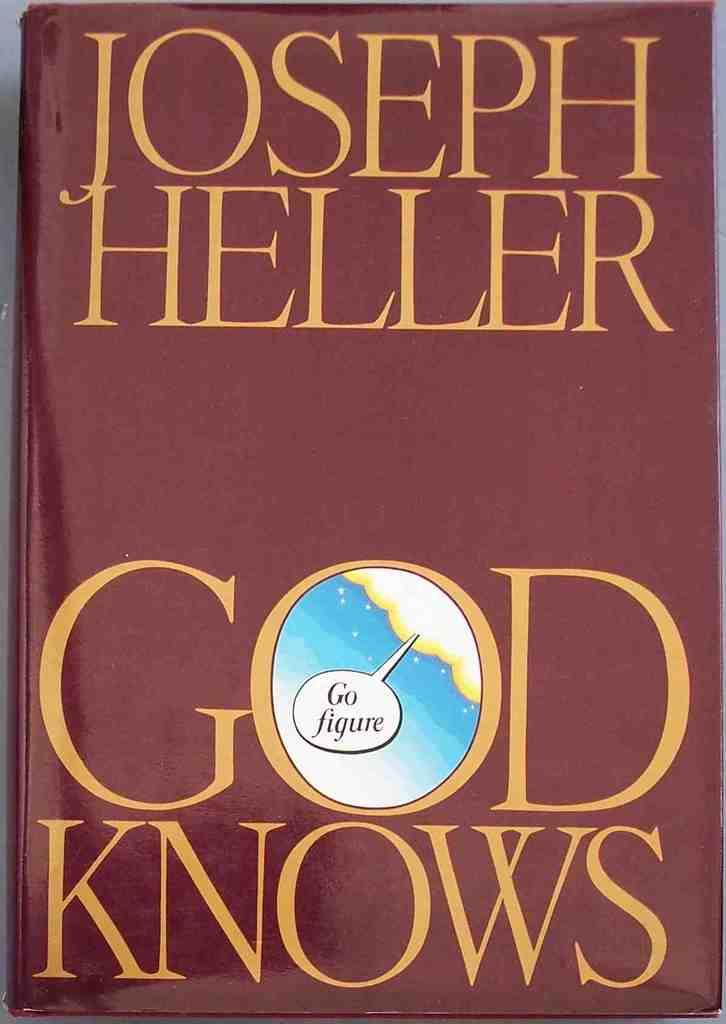Who is the author?
Ensure brevity in your answer.  Joseph heller. Is this a religious book?
Provide a succinct answer. Yes. 